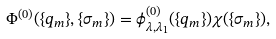Convert formula to latex. <formula><loc_0><loc_0><loc_500><loc_500>\Phi ^ { ( 0 ) } ( \{ q _ { m } \} , \{ \sigma _ { m } \} ) = \phi _ { \lambda , \lambda _ { 1 } } ^ { ( 0 ) } ( \{ q _ { m } \} ) \chi ( \{ \sigma _ { m } \} ) ,</formula> 